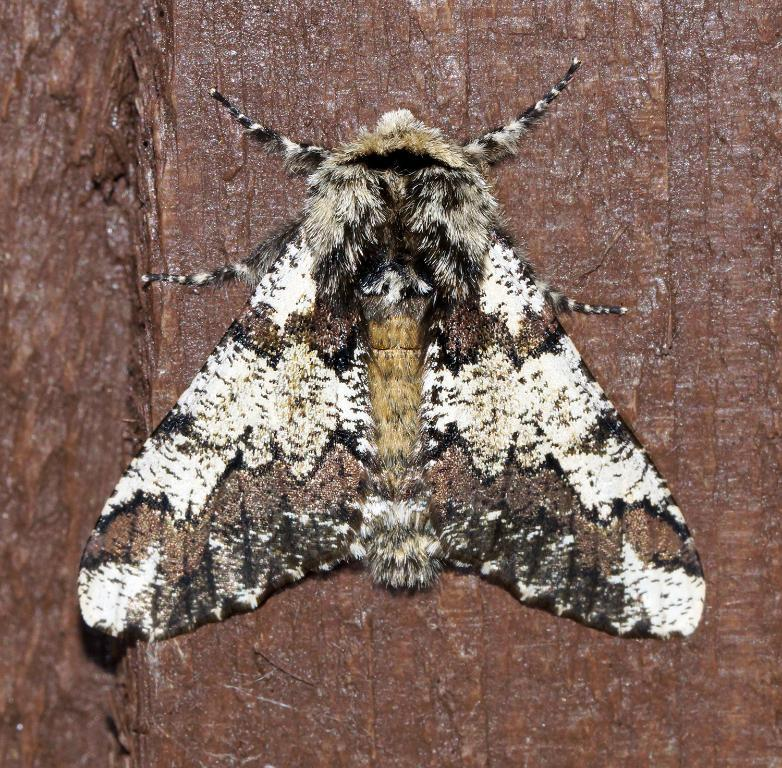What type of creature is present in the image? There is an insect in the image. Can you describe the coloration of the insect? The insect has a cream, brown, white, and black coloration. What is the insect resting on in the image? The insect is on a brown-colored object. What type of yarn is the fireman using to stretch in the image? There is no fireman or yarn present in the image; it features an insect on a brown-colored object. 